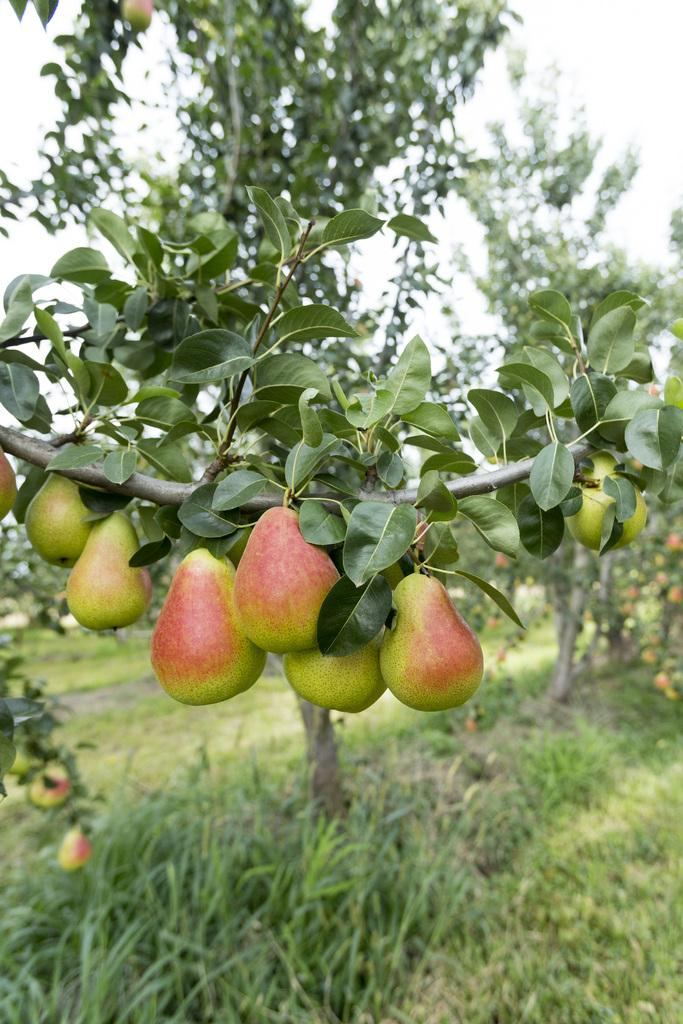What is in the foreground of the image? There is a tree branch with fruits and leaves in the foreground of the image. What can be seen in the background of the image? There are trees in the background of the image. What type of vegetation is at the bottom of the image? There is grass at the bottom of the image. Can you hear the boat's engine in the image? There is no boat or engine sound present in the image, as it features a tree branch with fruits and leaves, trees in the background, and grass at the bottom. 